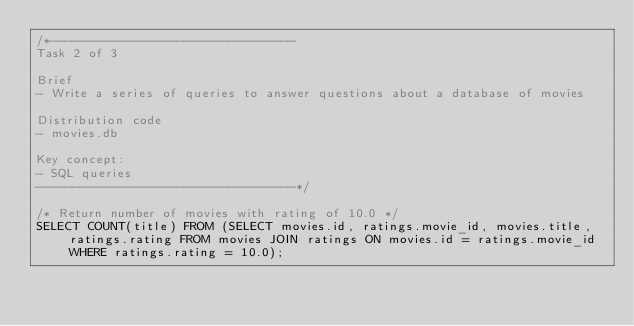Convert code to text. <code><loc_0><loc_0><loc_500><loc_500><_SQL_>/*---------------------------------
Task 2 of 3

Brief
- Write a series of queries to answer questions about a database of movies

Distribution code
- movies.db

Key concept:
- SQL queries
-----------------------------------*/

/* Return number of movies with rating of 10.0 */
SELECT COUNT(title) FROM (SELECT movies.id, ratings.movie_id, movies.title, ratings.rating FROM movies JOIN ratings ON movies.id = ratings.movie_id WHERE ratings.rating = 10.0);</code> 